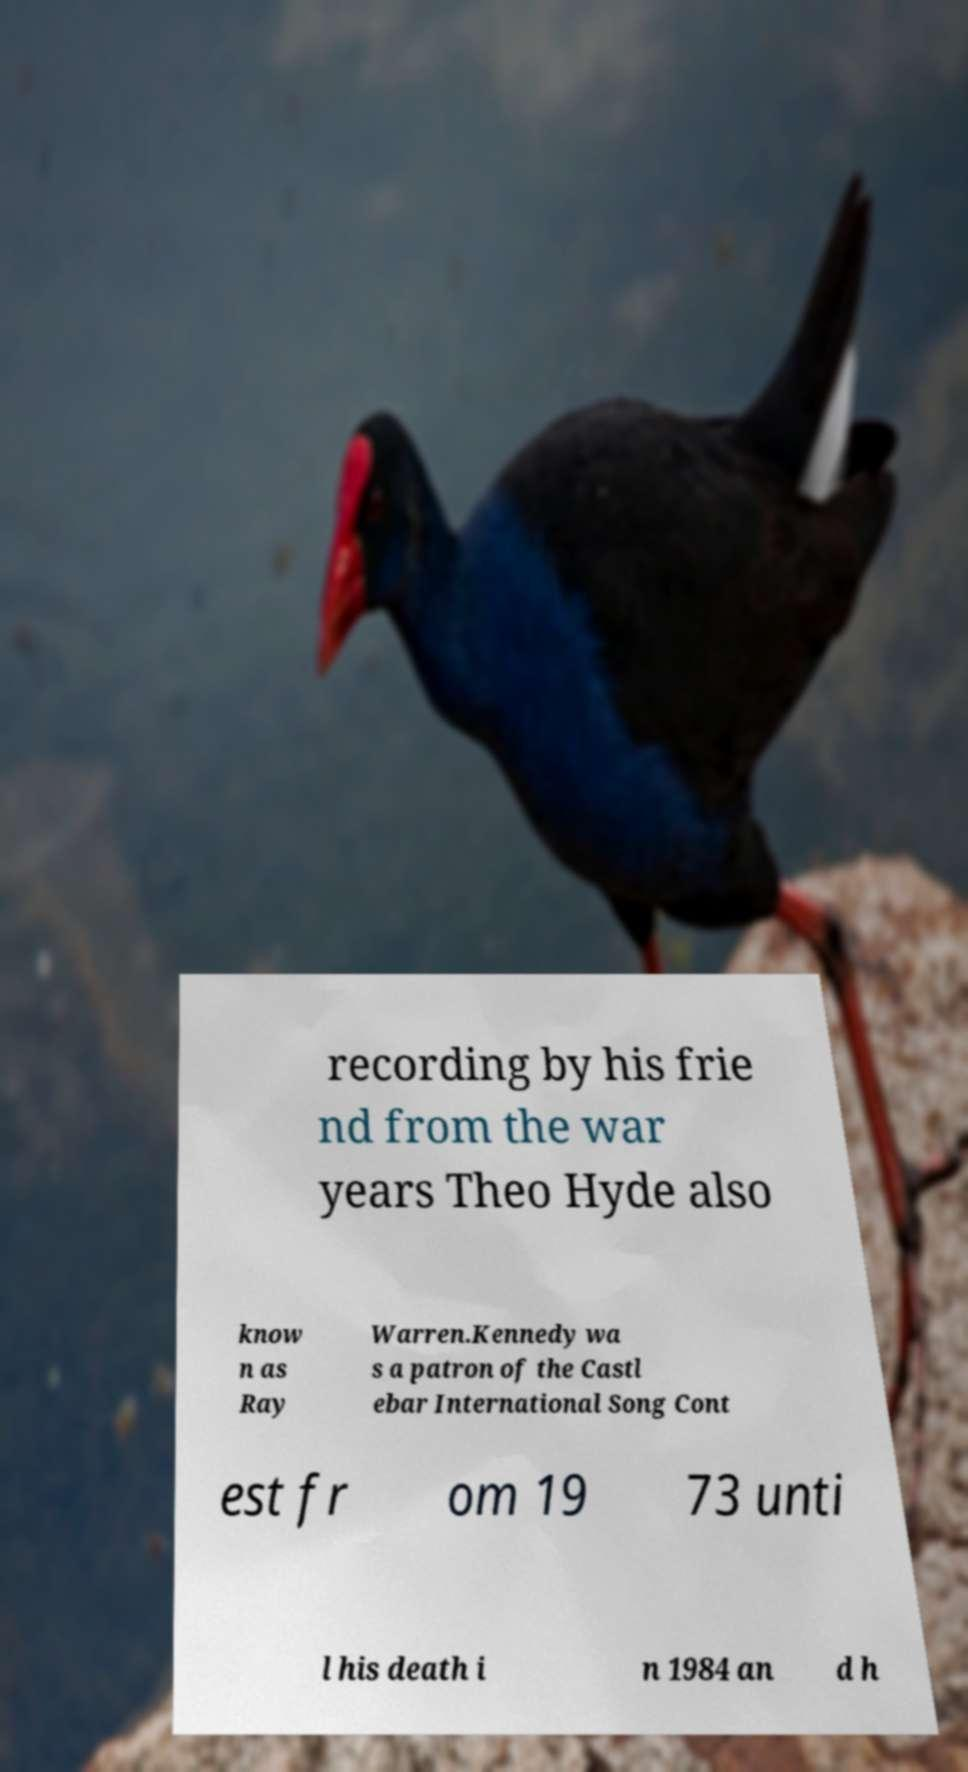Can you read and provide the text displayed in the image?This photo seems to have some interesting text. Can you extract and type it out for me? recording by his frie nd from the war years Theo Hyde also know n as Ray Warren.Kennedy wa s a patron of the Castl ebar International Song Cont est fr om 19 73 unti l his death i n 1984 an d h 